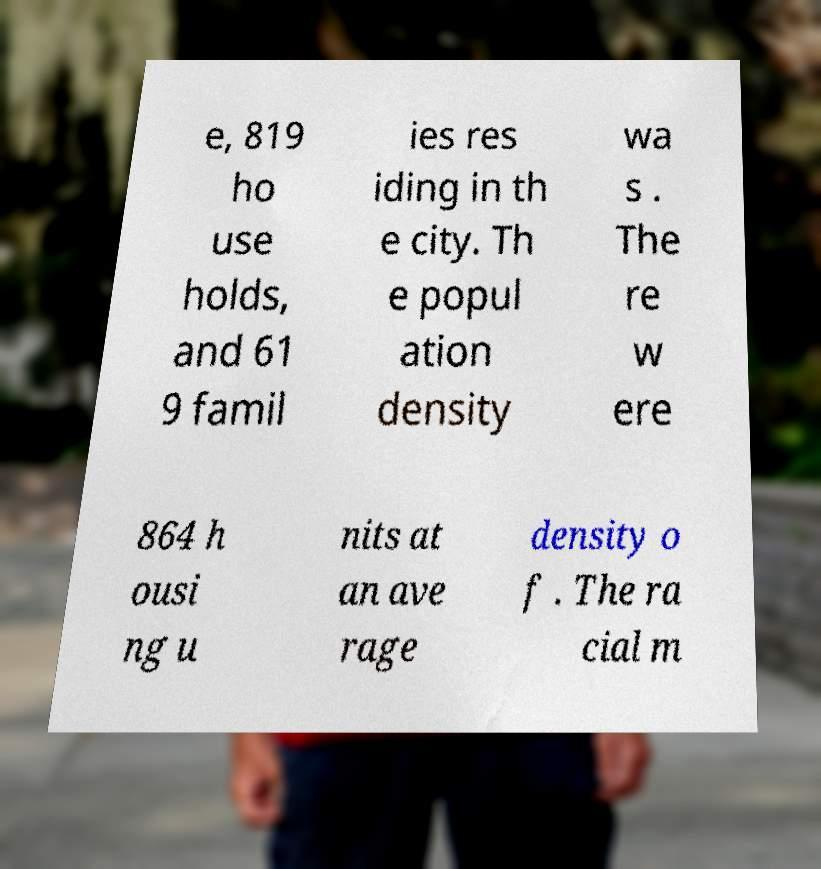Please identify and transcribe the text found in this image. e, 819 ho use holds, and 61 9 famil ies res iding in th e city. Th e popul ation density wa s . The re w ere 864 h ousi ng u nits at an ave rage density o f . The ra cial m 